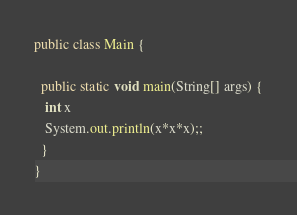<code> <loc_0><loc_0><loc_500><loc_500><_Java_>public class Main {

  public static void main(String[] args) {
   int x 
   System.out.println(x*x*x);;
  }
}</code> 